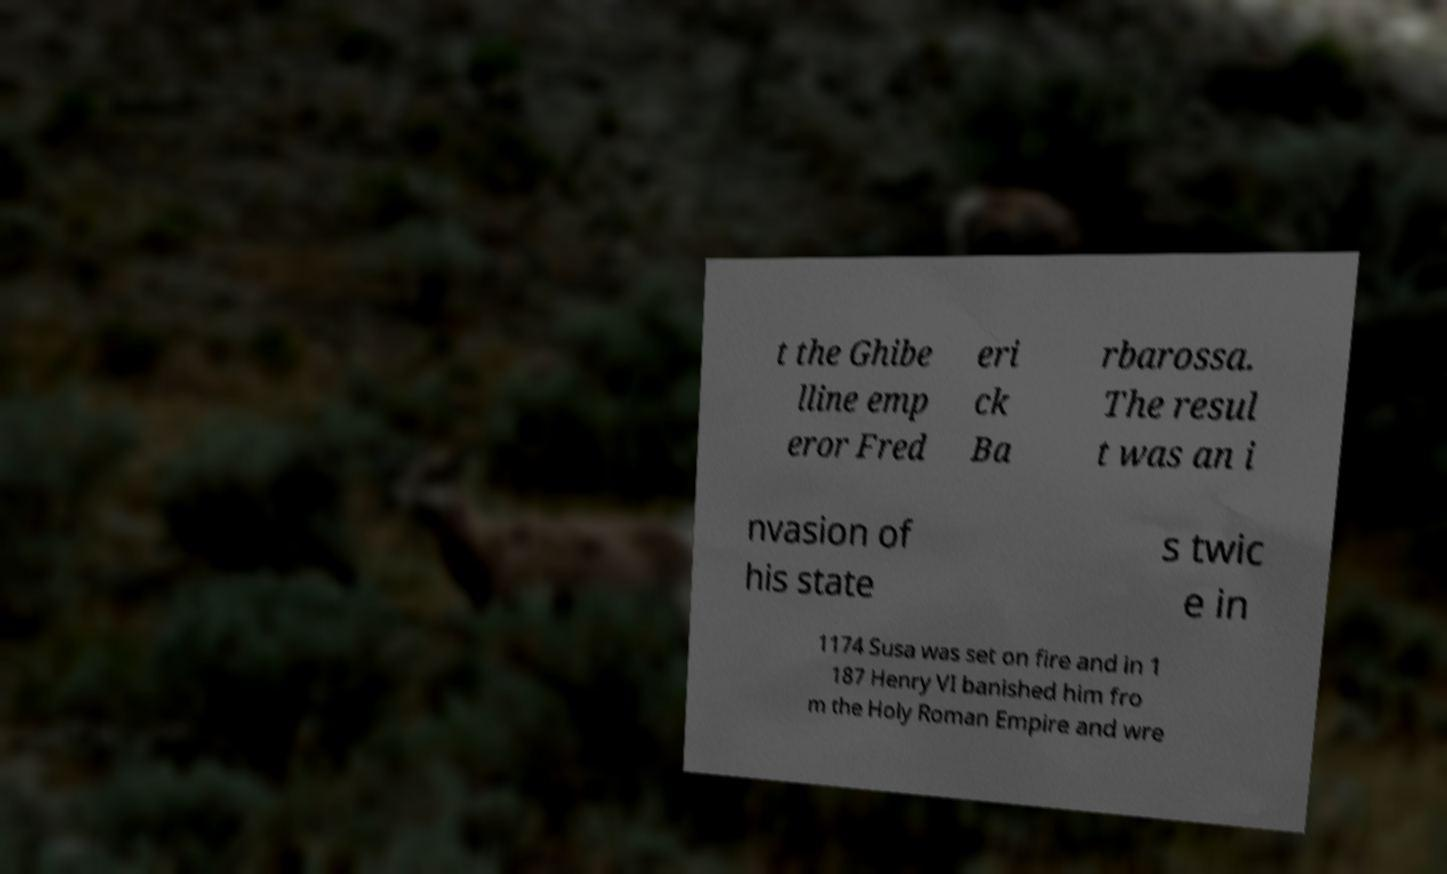For documentation purposes, I need the text within this image transcribed. Could you provide that? t the Ghibe lline emp eror Fred eri ck Ba rbarossa. The resul t was an i nvasion of his state s twic e in 1174 Susa was set on fire and in 1 187 Henry VI banished him fro m the Holy Roman Empire and wre 